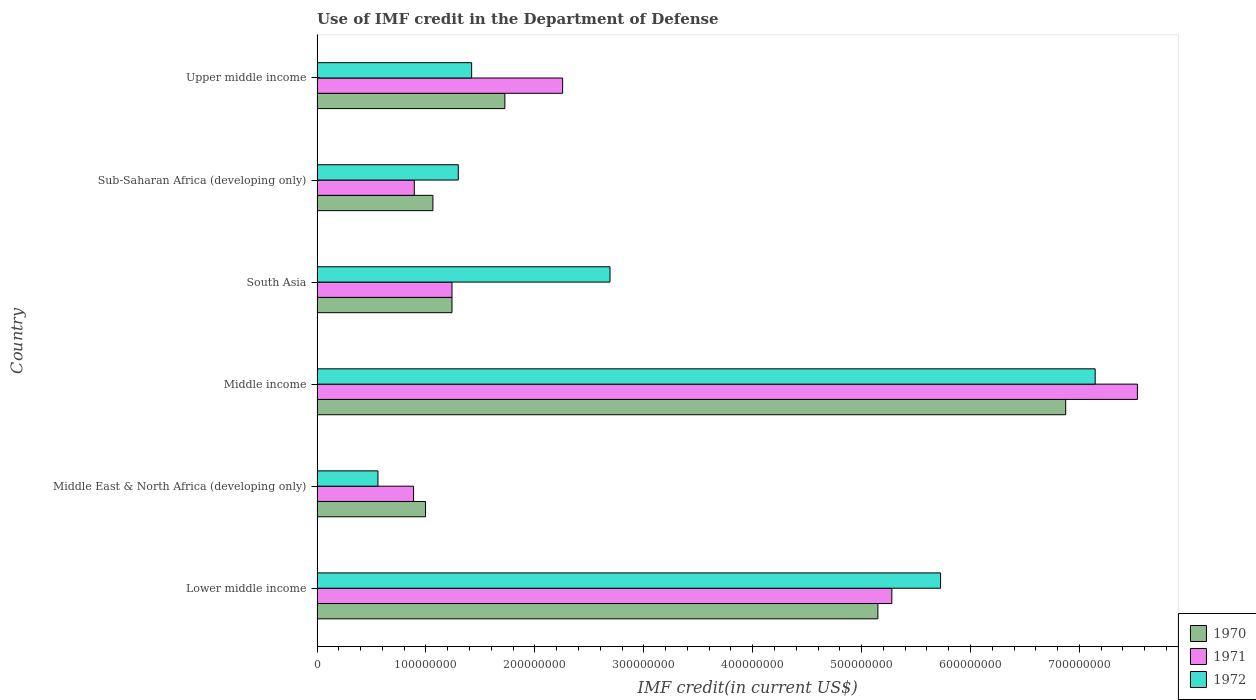How many groups of bars are there?
Ensure brevity in your answer.  6. Are the number of bars per tick equal to the number of legend labels?
Provide a short and direct response. Yes. Are the number of bars on each tick of the Y-axis equal?
Keep it short and to the point. Yes. How many bars are there on the 3rd tick from the bottom?
Offer a terse response. 3. What is the label of the 6th group of bars from the top?
Your response must be concise. Lower middle income. In how many cases, is the number of bars for a given country not equal to the number of legend labels?
Ensure brevity in your answer.  0. What is the IMF credit in the Department of Defense in 1972 in South Asia?
Make the answer very short. 2.69e+08. Across all countries, what is the maximum IMF credit in the Department of Defense in 1970?
Ensure brevity in your answer.  6.87e+08. Across all countries, what is the minimum IMF credit in the Department of Defense in 1970?
Give a very brief answer. 9.96e+07. In which country was the IMF credit in the Department of Defense in 1972 maximum?
Give a very brief answer. Middle income. In which country was the IMF credit in the Department of Defense in 1970 minimum?
Provide a succinct answer. Middle East & North Africa (developing only). What is the total IMF credit in the Department of Defense in 1971 in the graph?
Keep it short and to the point. 1.81e+09. What is the difference between the IMF credit in the Department of Defense in 1970 in Middle East & North Africa (developing only) and that in Sub-Saharan Africa (developing only)?
Keep it short and to the point. -6.78e+06. What is the difference between the IMF credit in the Department of Defense in 1971 in Lower middle income and the IMF credit in the Department of Defense in 1970 in Sub-Saharan Africa (developing only)?
Offer a terse response. 4.21e+08. What is the average IMF credit in the Department of Defense in 1970 per country?
Offer a terse response. 2.84e+08. What is the difference between the IMF credit in the Department of Defense in 1971 and IMF credit in the Department of Defense in 1970 in Middle income?
Keep it short and to the point. 6.58e+07. What is the ratio of the IMF credit in the Department of Defense in 1970 in South Asia to that in Upper middle income?
Your answer should be very brief. 0.72. Is the IMF credit in the Department of Defense in 1971 in Lower middle income less than that in Middle income?
Make the answer very short. Yes. Is the difference between the IMF credit in the Department of Defense in 1971 in Middle East & North Africa (developing only) and Sub-Saharan Africa (developing only) greater than the difference between the IMF credit in the Department of Defense in 1970 in Middle East & North Africa (developing only) and Sub-Saharan Africa (developing only)?
Your response must be concise. Yes. What is the difference between the highest and the second highest IMF credit in the Department of Defense in 1972?
Keep it short and to the point. 1.42e+08. What is the difference between the highest and the lowest IMF credit in the Department of Defense in 1970?
Ensure brevity in your answer.  5.88e+08. In how many countries, is the IMF credit in the Department of Defense in 1972 greater than the average IMF credit in the Department of Defense in 1972 taken over all countries?
Make the answer very short. 2. Is it the case that in every country, the sum of the IMF credit in the Department of Defense in 1971 and IMF credit in the Department of Defense in 1972 is greater than the IMF credit in the Department of Defense in 1970?
Provide a succinct answer. Yes. How many bars are there?
Offer a very short reply. 18. Are all the bars in the graph horizontal?
Give a very brief answer. Yes. How many countries are there in the graph?
Keep it short and to the point. 6. Does the graph contain grids?
Provide a succinct answer. No. Where does the legend appear in the graph?
Give a very brief answer. Bottom right. How many legend labels are there?
Offer a very short reply. 3. How are the legend labels stacked?
Make the answer very short. Vertical. What is the title of the graph?
Make the answer very short. Use of IMF credit in the Department of Defense. What is the label or title of the X-axis?
Offer a very short reply. IMF credit(in current US$). What is the IMF credit(in current US$) in 1970 in Lower middle income?
Make the answer very short. 5.15e+08. What is the IMF credit(in current US$) of 1971 in Lower middle income?
Your answer should be very brief. 5.28e+08. What is the IMF credit(in current US$) in 1972 in Lower middle income?
Make the answer very short. 5.73e+08. What is the IMF credit(in current US$) in 1970 in Middle East & North Africa (developing only)?
Make the answer very short. 9.96e+07. What is the IMF credit(in current US$) of 1971 in Middle East & North Africa (developing only)?
Keep it short and to the point. 8.86e+07. What is the IMF credit(in current US$) in 1972 in Middle East & North Africa (developing only)?
Offer a terse response. 5.59e+07. What is the IMF credit(in current US$) in 1970 in Middle income?
Offer a very short reply. 6.87e+08. What is the IMF credit(in current US$) of 1971 in Middle income?
Offer a terse response. 7.53e+08. What is the IMF credit(in current US$) of 1972 in Middle income?
Make the answer very short. 7.14e+08. What is the IMF credit(in current US$) of 1970 in South Asia?
Offer a very short reply. 1.24e+08. What is the IMF credit(in current US$) in 1971 in South Asia?
Ensure brevity in your answer.  1.24e+08. What is the IMF credit(in current US$) of 1972 in South Asia?
Your response must be concise. 2.69e+08. What is the IMF credit(in current US$) of 1970 in Sub-Saharan Africa (developing only)?
Your answer should be very brief. 1.06e+08. What is the IMF credit(in current US$) of 1971 in Sub-Saharan Africa (developing only)?
Offer a terse response. 8.93e+07. What is the IMF credit(in current US$) in 1972 in Sub-Saharan Africa (developing only)?
Offer a very short reply. 1.30e+08. What is the IMF credit(in current US$) of 1970 in Upper middle income?
Offer a very short reply. 1.72e+08. What is the IMF credit(in current US$) of 1971 in Upper middle income?
Your response must be concise. 2.25e+08. What is the IMF credit(in current US$) in 1972 in Upper middle income?
Your answer should be compact. 1.42e+08. Across all countries, what is the maximum IMF credit(in current US$) in 1970?
Offer a very short reply. 6.87e+08. Across all countries, what is the maximum IMF credit(in current US$) of 1971?
Your response must be concise. 7.53e+08. Across all countries, what is the maximum IMF credit(in current US$) in 1972?
Offer a terse response. 7.14e+08. Across all countries, what is the minimum IMF credit(in current US$) in 1970?
Offer a terse response. 9.96e+07. Across all countries, what is the minimum IMF credit(in current US$) of 1971?
Provide a succinct answer. 8.86e+07. Across all countries, what is the minimum IMF credit(in current US$) of 1972?
Offer a very short reply. 5.59e+07. What is the total IMF credit(in current US$) of 1970 in the graph?
Ensure brevity in your answer.  1.70e+09. What is the total IMF credit(in current US$) in 1971 in the graph?
Provide a succinct answer. 1.81e+09. What is the total IMF credit(in current US$) in 1972 in the graph?
Make the answer very short. 1.88e+09. What is the difference between the IMF credit(in current US$) of 1970 in Lower middle income and that in Middle East & North Africa (developing only)?
Your answer should be compact. 4.15e+08. What is the difference between the IMF credit(in current US$) in 1971 in Lower middle income and that in Middle East & North Africa (developing only)?
Your answer should be compact. 4.39e+08. What is the difference between the IMF credit(in current US$) of 1972 in Lower middle income and that in Middle East & North Africa (developing only)?
Provide a short and direct response. 5.17e+08. What is the difference between the IMF credit(in current US$) in 1970 in Lower middle income and that in Middle income?
Your answer should be compact. -1.72e+08. What is the difference between the IMF credit(in current US$) of 1971 in Lower middle income and that in Middle income?
Offer a terse response. -2.25e+08. What is the difference between the IMF credit(in current US$) in 1972 in Lower middle income and that in Middle income?
Provide a succinct answer. -1.42e+08. What is the difference between the IMF credit(in current US$) in 1970 in Lower middle income and that in South Asia?
Make the answer very short. 3.91e+08. What is the difference between the IMF credit(in current US$) in 1971 in Lower middle income and that in South Asia?
Your response must be concise. 4.04e+08. What is the difference between the IMF credit(in current US$) of 1972 in Lower middle income and that in South Asia?
Your response must be concise. 3.04e+08. What is the difference between the IMF credit(in current US$) of 1970 in Lower middle income and that in Sub-Saharan Africa (developing only)?
Give a very brief answer. 4.09e+08. What is the difference between the IMF credit(in current US$) of 1971 in Lower middle income and that in Sub-Saharan Africa (developing only)?
Give a very brief answer. 4.38e+08. What is the difference between the IMF credit(in current US$) of 1972 in Lower middle income and that in Sub-Saharan Africa (developing only)?
Offer a very short reply. 4.43e+08. What is the difference between the IMF credit(in current US$) of 1970 in Lower middle income and that in Upper middle income?
Make the answer very short. 3.43e+08. What is the difference between the IMF credit(in current US$) of 1971 in Lower middle income and that in Upper middle income?
Your answer should be compact. 3.02e+08. What is the difference between the IMF credit(in current US$) of 1972 in Lower middle income and that in Upper middle income?
Offer a very short reply. 4.31e+08. What is the difference between the IMF credit(in current US$) of 1970 in Middle East & North Africa (developing only) and that in Middle income?
Your answer should be compact. -5.88e+08. What is the difference between the IMF credit(in current US$) in 1971 in Middle East & North Africa (developing only) and that in Middle income?
Your answer should be compact. -6.65e+08. What is the difference between the IMF credit(in current US$) in 1972 in Middle East & North Africa (developing only) and that in Middle income?
Provide a short and direct response. -6.59e+08. What is the difference between the IMF credit(in current US$) of 1970 in Middle East & North Africa (developing only) and that in South Asia?
Ensure brevity in your answer.  -2.43e+07. What is the difference between the IMF credit(in current US$) of 1971 in Middle East & North Africa (developing only) and that in South Asia?
Offer a terse response. -3.53e+07. What is the difference between the IMF credit(in current US$) in 1972 in Middle East & North Africa (developing only) and that in South Asia?
Ensure brevity in your answer.  -2.13e+08. What is the difference between the IMF credit(in current US$) in 1970 in Middle East & North Africa (developing only) and that in Sub-Saharan Africa (developing only)?
Your response must be concise. -6.78e+06. What is the difference between the IMF credit(in current US$) of 1971 in Middle East & North Africa (developing only) and that in Sub-Saharan Africa (developing only)?
Your answer should be very brief. -6.60e+05. What is the difference between the IMF credit(in current US$) of 1972 in Middle East & North Africa (developing only) and that in Sub-Saharan Africa (developing only)?
Provide a short and direct response. -7.38e+07. What is the difference between the IMF credit(in current US$) of 1970 in Middle East & North Africa (developing only) and that in Upper middle income?
Offer a terse response. -7.28e+07. What is the difference between the IMF credit(in current US$) of 1971 in Middle East & North Africa (developing only) and that in Upper middle income?
Your answer should be compact. -1.37e+08. What is the difference between the IMF credit(in current US$) in 1972 in Middle East & North Africa (developing only) and that in Upper middle income?
Offer a very short reply. -8.60e+07. What is the difference between the IMF credit(in current US$) in 1970 in Middle income and that in South Asia?
Your response must be concise. 5.64e+08. What is the difference between the IMF credit(in current US$) in 1971 in Middle income and that in South Asia?
Ensure brevity in your answer.  6.29e+08. What is the difference between the IMF credit(in current US$) of 1972 in Middle income and that in South Asia?
Your answer should be very brief. 4.45e+08. What is the difference between the IMF credit(in current US$) in 1970 in Middle income and that in Sub-Saharan Africa (developing only)?
Provide a short and direct response. 5.81e+08. What is the difference between the IMF credit(in current US$) in 1971 in Middle income and that in Sub-Saharan Africa (developing only)?
Your answer should be very brief. 6.64e+08. What is the difference between the IMF credit(in current US$) of 1972 in Middle income and that in Sub-Saharan Africa (developing only)?
Ensure brevity in your answer.  5.85e+08. What is the difference between the IMF credit(in current US$) of 1970 in Middle income and that in Upper middle income?
Your response must be concise. 5.15e+08. What is the difference between the IMF credit(in current US$) of 1971 in Middle income and that in Upper middle income?
Give a very brief answer. 5.28e+08. What is the difference between the IMF credit(in current US$) in 1972 in Middle income and that in Upper middle income?
Your answer should be very brief. 5.73e+08. What is the difference between the IMF credit(in current US$) of 1970 in South Asia and that in Sub-Saharan Africa (developing only)?
Give a very brief answer. 1.75e+07. What is the difference between the IMF credit(in current US$) in 1971 in South Asia and that in Sub-Saharan Africa (developing only)?
Provide a succinct answer. 3.46e+07. What is the difference between the IMF credit(in current US$) of 1972 in South Asia and that in Sub-Saharan Africa (developing only)?
Your response must be concise. 1.39e+08. What is the difference between the IMF credit(in current US$) in 1970 in South Asia and that in Upper middle income?
Ensure brevity in your answer.  -4.86e+07. What is the difference between the IMF credit(in current US$) in 1971 in South Asia and that in Upper middle income?
Offer a terse response. -1.02e+08. What is the difference between the IMF credit(in current US$) of 1972 in South Asia and that in Upper middle income?
Keep it short and to the point. 1.27e+08. What is the difference between the IMF credit(in current US$) of 1970 in Sub-Saharan Africa (developing only) and that in Upper middle income?
Your answer should be very brief. -6.61e+07. What is the difference between the IMF credit(in current US$) in 1971 in Sub-Saharan Africa (developing only) and that in Upper middle income?
Your answer should be very brief. -1.36e+08. What is the difference between the IMF credit(in current US$) in 1972 in Sub-Saharan Africa (developing only) and that in Upper middle income?
Provide a short and direct response. -1.23e+07. What is the difference between the IMF credit(in current US$) of 1970 in Lower middle income and the IMF credit(in current US$) of 1971 in Middle East & North Africa (developing only)?
Your answer should be compact. 4.26e+08. What is the difference between the IMF credit(in current US$) of 1970 in Lower middle income and the IMF credit(in current US$) of 1972 in Middle East & North Africa (developing only)?
Make the answer very short. 4.59e+08. What is the difference between the IMF credit(in current US$) of 1971 in Lower middle income and the IMF credit(in current US$) of 1972 in Middle East & North Africa (developing only)?
Your answer should be compact. 4.72e+08. What is the difference between the IMF credit(in current US$) of 1970 in Lower middle income and the IMF credit(in current US$) of 1971 in Middle income?
Keep it short and to the point. -2.38e+08. What is the difference between the IMF credit(in current US$) in 1970 in Lower middle income and the IMF credit(in current US$) in 1972 in Middle income?
Make the answer very short. -2.00e+08. What is the difference between the IMF credit(in current US$) of 1971 in Lower middle income and the IMF credit(in current US$) of 1972 in Middle income?
Offer a terse response. -1.87e+08. What is the difference between the IMF credit(in current US$) of 1970 in Lower middle income and the IMF credit(in current US$) of 1971 in South Asia?
Your response must be concise. 3.91e+08. What is the difference between the IMF credit(in current US$) of 1970 in Lower middle income and the IMF credit(in current US$) of 1972 in South Asia?
Give a very brief answer. 2.46e+08. What is the difference between the IMF credit(in current US$) of 1971 in Lower middle income and the IMF credit(in current US$) of 1972 in South Asia?
Offer a very short reply. 2.59e+08. What is the difference between the IMF credit(in current US$) in 1970 in Lower middle income and the IMF credit(in current US$) in 1971 in Sub-Saharan Africa (developing only)?
Provide a succinct answer. 4.26e+08. What is the difference between the IMF credit(in current US$) in 1970 in Lower middle income and the IMF credit(in current US$) in 1972 in Sub-Saharan Africa (developing only)?
Provide a short and direct response. 3.85e+08. What is the difference between the IMF credit(in current US$) of 1971 in Lower middle income and the IMF credit(in current US$) of 1972 in Sub-Saharan Africa (developing only)?
Your response must be concise. 3.98e+08. What is the difference between the IMF credit(in current US$) in 1970 in Lower middle income and the IMF credit(in current US$) in 1971 in Upper middle income?
Offer a very short reply. 2.89e+08. What is the difference between the IMF credit(in current US$) in 1970 in Lower middle income and the IMF credit(in current US$) in 1972 in Upper middle income?
Provide a succinct answer. 3.73e+08. What is the difference between the IMF credit(in current US$) of 1971 in Lower middle income and the IMF credit(in current US$) of 1972 in Upper middle income?
Offer a very short reply. 3.86e+08. What is the difference between the IMF credit(in current US$) in 1970 in Middle East & North Africa (developing only) and the IMF credit(in current US$) in 1971 in Middle income?
Give a very brief answer. -6.54e+08. What is the difference between the IMF credit(in current US$) in 1970 in Middle East & North Africa (developing only) and the IMF credit(in current US$) in 1972 in Middle income?
Provide a short and direct response. -6.15e+08. What is the difference between the IMF credit(in current US$) in 1971 in Middle East & North Africa (developing only) and the IMF credit(in current US$) in 1972 in Middle income?
Your answer should be compact. -6.26e+08. What is the difference between the IMF credit(in current US$) in 1970 in Middle East & North Africa (developing only) and the IMF credit(in current US$) in 1971 in South Asia?
Your answer should be very brief. -2.43e+07. What is the difference between the IMF credit(in current US$) of 1970 in Middle East & North Africa (developing only) and the IMF credit(in current US$) of 1972 in South Asia?
Give a very brief answer. -1.69e+08. What is the difference between the IMF credit(in current US$) of 1971 in Middle East & North Africa (developing only) and the IMF credit(in current US$) of 1972 in South Asia?
Your answer should be very brief. -1.80e+08. What is the difference between the IMF credit(in current US$) in 1970 in Middle East & North Africa (developing only) and the IMF credit(in current US$) in 1971 in Sub-Saharan Africa (developing only)?
Give a very brief answer. 1.03e+07. What is the difference between the IMF credit(in current US$) in 1970 in Middle East & North Africa (developing only) and the IMF credit(in current US$) in 1972 in Sub-Saharan Africa (developing only)?
Provide a short and direct response. -3.01e+07. What is the difference between the IMF credit(in current US$) of 1971 in Middle East & North Africa (developing only) and the IMF credit(in current US$) of 1972 in Sub-Saharan Africa (developing only)?
Offer a terse response. -4.11e+07. What is the difference between the IMF credit(in current US$) in 1970 in Middle East & North Africa (developing only) and the IMF credit(in current US$) in 1971 in Upper middle income?
Give a very brief answer. -1.26e+08. What is the difference between the IMF credit(in current US$) of 1970 in Middle East & North Africa (developing only) and the IMF credit(in current US$) of 1972 in Upper middle income?
Give a very brief answer. -4.23e+07. What is the difference between the IMF credit(in current US$) in 1971 in Middle East & North Africa (developing only) and the IMF credit(in current US$) in 1972 in Upper middle income?
Your answer should be very brief. -5.33e+07. What is the difference between the IMF credit(in current US$) in 1970 in Middle income and the IMF credit(in current US$) in 1971 in South Asia?
Make the answer very short. 5.64e+08. What is the difference between the IMF credit(in current US$) of 1970 in Middle income and the IMF credit(in current US$) of 1972 in South Asia?
Ensure brevity in your answer.  4.18e+08. What is the difference between the IMF credit(in current US$) of 1971 in Middle income and the IMF credit(in current US$) of 1972 in South Asia?
Your answer should be compact. 4.84e+08. What is the difference between the IMF credit(in current US$) of 1970 in Middle income and the IMF credit(in current US$) of 1971 in Sub-Saharan Africa (developing only)?
Ensure brevity in your answer.  5.98e+08. What is the difference between the IMF credit(in current US$) in 1970 in Middle income and the IMF credit(in current US$) in 1972 in Sub-Saharan Africa (developing only)?
Make the answer very short. 5.58e+08. What is the difference between the IMF credit(in current US$) in 1971 in Middle income and the IMF credit(in current US$) in 1972 in Sub-Saharan Africa (developing only)?
Offer a very short reply. 6.24e+08. What is the difference between the IMF credit(in current US$) of 1970 in Middle income and the IMF credit(in current US$) of 1971 in Upper middle income?
Provide a short and direct response. 4.62e+08. What is the difference between the IMF credit(in current US$) of 1970 in Middle income and the IMF credit(in current US$) of 1972 in Upper middle income?
Your response must be concise. 5.45e+08. What is the difference between the IMF credit(in current US$) in 1971 in Middle income and the IMF credit(in current US$) in 1972 in Upper middle income?
Offer a very short reply. 6.11e+08. What is the difference between the IMF credit(in current US$) in 1970 in South Asia and the IMF credit(in current US$) in 1971 in Sub-Saharan Africa (developing only)?
Make the answer very short. 3.46e+07. What is the difference between the IMF credit(in current US$) of 1970 in South Asia and the IMF credit(in current US$) of 1972 in Sub-Saharan Africa (developing only)?
Offer a very short reply. -5.79e+06. What is the difference between the IMF credit(in current US$) of 1971 in South Asia and the IMF credit(in current US$) of 1972 in Sub-Saharan Africa (developing only)?
Your response must be concise. -5.79e+06. What is the difference between the IMF credit(in current US$) in 1970 in South Asia and the IMF credit(in current US$) in 1971 in Upper middle income?
Offer a terse response. -1.02e+08. What is the difference between the IMF credit(in current US$) in 1970 in South Asia and the IMF credit(in current US$) in 1972 in Upper middle income?
Your answer should be very brief. -1.80e+07. What is the difference between the IMF credit(in current US$) of 1971 in South Asia and the IMF credit(in current US$) of 1972 in Upper middle income?
Your response must be concise. -1.80e+07. What is the difference between the IMF credit(in current US$) in 1970 in Sub-Saharan Africa (developing only) and the IMF credit(in current US$) in 1971 in Upper middle income?
Your answer should be compact. -1.19e+08. What is the difference between the IMF credit(in current US$) in 1970 in Sub-Saharan Africa (developing only) and the IMF credit(in current US$) in 1972 in Upper middle income?
Make the answer very short. -3.56e+07. What is the difference between the IMF credit(in current US$) of 1971 in Sub-Saharan Africa (developing only) and the IMF credit(in current US$) of 1972 in Upper middle income?
Provide a succinct answer. -5.27e+07. What is the average IMF credit(in current US$) in 1970 per country?
Provide a succinct answer. 2.84e+08. What is the average IMF credit(in current US$) in 1971 per country?
Your response must be concise. 3.01e+08. What is the average IMF credit(in current US$) in 1972 per country?
Your response must be concise. 3.14e+08. What is the difference between the IMF credit(in current US$) of 1970 and IMF credit(in current US$) of 1971 in Lower middle income?
Make the answer very short. -1.28e+07. What is the difference between the IMF credit(in current US$) in 1970 and IMF credit(in current US$) in 1972 in Lower middle income?
Provide a succinct answer. -5.76e+07. What is the difference between the IMF credit(in current US$) in 1971 and IMF credit(in current US$) in 1972 in Lower middle income?
Make the answer very short. -4.48e+07. What is the difference between the IMF credit(in current US$) of 1970 and IMF credit(in current US$) of 1971 in Middle East & North Africa (developing only)?
Your response must be concise. 1.10e+07. What is the difference between the IMF credit(in current US$) of 1970 and IMF credit(in current US$) of 1972 in Middle East & North Africa (developing only)?
Ensure brevity in your answer.  4.37e+07. What is the difference between the IMF credit(in current US$) in 1971 and IMF credit(in current US$) in 1972 in Middle East & North Africa (developing only)?
Make the answer very short. 3.27e+07. What is the difference between the IMF credit(in current US$) in 1970 and IMF credit(in current US$) in 1971 in Middle income?
Provide a short and direct response. -6.58e+07. What is the difference between the IMF credit(in current US$) of 1970 and IMF credit(in current US$) of 1972 in Middle income?
Give a very brief answer. -2.71e+07. What is the difference between the IMF credit(in current US$) in 1971 and IMF credit(in current US$) in 1972 in Middle income?
Your response must be concise. 3.88e+07. What is the difference between the IMF credit(in current US$) of 1970 and IMF credit(in current US$) of 1972 in South Asia?
Offer a very short reply. -1.45e+08. What is the difference between the IMF credit(in current US$) in 1971 and IMF credit(in current US$) in 1972 in South Asia?
Provide a short and direct response. -1.45e+08. What is the difference between the IMF credit(in current US$) of 1970 and IMF credit(in current US$) of 1971 in Sub-Saharan Africa (developing only)?
Provide a succinct answer. 1.71e+07. What is the difference between the IMF credit(in current US$) in 1970 and IMF credit(in current US$) in 1972 in Sub-Saharan Africa (developing only)?
Your answer should be compact. -2.33e+07. What is the difference between the IMF credit(in current US$) in 1971 and IMF credit(in current US$) in 1972 in Sub-Saharan Africa (developing only)?
Ensure brevity in your answer.  -4.04e+07. What is the difference between the IMF credit(in current US$) of 1970 and IMF credit(in current US$) of 1971 in Upper middle income?
Make the answer very short. -5.30e+07. What is the difference between the IMF credit(in current US$) of 1970 and IMF credit(in current US$) of 1972 in Upper middle income?
Your response must be concise. 3.05e+07. What is the difference between the IMF credit(in current US$) of 1971 and IMF credit(in current US$) of 1972 in Upper middle income?
Make the answer very short. 8.35e+07. What is the ratio of the IMF credit(in current US$) in 1970 in Lower middle income to that in Middle East & North Africa (developing only)?
Provide a short and direct response. 5.17. What is the ratio of the IMF credit(in current US$) in 1971 in Lower middle income to that in Middle East & North Africa (developing only)?
Provide a short and direct response. 5.95. What is the ratio of the IMF credit(in current US$) of 1972 in Lower middle income to that in Middle East & North Africa (developing only)?
Make the answer very short. 10.24. What is the ratio of the IMF credit(in current US$) in 1970 in Lower middle income to that in Middle income?
Ensure brevity in your answer.  0.75. What is the ratio of the IMF credit(in current US$) in 1971 in Lower middle income to that in Middle income?
Give a very brief answer. 0.7. What is the ratio of the IMF credit(in current US$) of 1972 in Lower middle income to that in Middle income?
Ensure brevity in your answer.  0.8. What is the ratio of the IMF credit(in current US$) of 1970 in Lower middle income to that in South Asia?
Your answer should be very brief. 4.16. What is the ratio of the IMF credit(in current US$) in 1971 in Lower middle income to that in South Asia?
Your answer should be very brief. 4.26. What is the ratio of the IMF credit(in current US$) of 1972 in Lower middle income to that in South Asia?
Your response must be concise. 2.13. What is the ratio of the IMF credit(in current US$) of 1970 in Lower middle income to that in Sub-Saharan Africa (developing only)?
Provide a short and direct response. 4.84. What is the ratio of the IMF credit(in current US$) in 1971 in Lower middle income to that in Sub-Saharan Africa (developing only)?
Your answer should be compact. 5.91. What is the ratio of the IMF credit(in current US$) of 1972 in Lower middle income to that in Sub-Saharan Africa (developing only)?
Provide a short and direct response. 4.41. What is the ratio of the IMF credit(in current US$) in 1970 in Lower middle income to that in Upper middle income?
Give a very brief answer. 2.99. What is the ratio of the IMF credit(in current US$) in 1971 in Lower middle income to that in Upper middle income?
Give a very brief answer. 2.34. What is the ratio of the IMF credit(in current US$) of 1972 in Lower middle income to that in Upper middle income?
Your response must be concise. 4.03. What is the ratio of the IMF credit(in current US$) in 1970 in Middle East & North Africa (developing only) to that in Middle income?
Your answer should be very brief. 0.14. What is the ratio of the IMF credit(in current US$) of 1971 in Middle East & North Africa (developing only) to that in Middle income?
Your answer should be very brief. 0.12. What is the ratio of the IMF credit(in current US$) in 1972 in Middle East & North Africa (developing only) to that in Middle income?
Make the answer very short. 0.08. What is the ratio of the IMF credit(in current US$) of 1970 in Middle East & North Africa (developing only) to that in South Asia?
Offer a terse response. 0.8. What is the ratio of the IMF credit(in current US$) of 1971 in Middle East & North Africa (developing only) to that in South Asia?
Your answer should be compact. 0.72. What is the ratio of the IMF credit(in current US$) of 1972 in Middle East & North Africa (developing only) to that in South Asia?
Provide a short and direct response. 0.21. What is the ratio of the IMF credit(in current US$) in 1970 in Middle East & North Africa (developing only) to that in Sub-Saharan Africa (developing only)?
Offer a very short reply. 0.94. What is the ratio of the IMF credit(in current US$) of 1971 in Middle East & North Africa (developing only) to that in Sub-Saharan Africa (developing only)?
Make the answer very short. 0.99. What is the ratio of the IMF credit(in current US$) in 1972 in Middle East & North Africa (developing only) to that in Sub-Saharan Africa (developing only)?
Offer a terse response. 0.43. What is the ratio of the IMF credit(in current US$) of 1970 in Middle East & North Africa (developing only) to that in Upper middle income?
Make the answer very short. 0.58. What is the ratio of the IMF credit(in current US$) of 1971 in Middle East & North Africa (developing only) to that in Upper middle income?
Give a very brief answer. 0.39. What is the ratio of the IMF credit(in current US$) of 1972 in Middle East & North Africa (developing only) to that in Upper middle income?
Your answer should be compact. 0.39. What is the ratio of the IMF credit(in current US$) in 1970 in Middle income to that in South Asia?
Your answer should be very brief. 5.55. What is the ratio of the IMF credit(in current US$) in 1971 in Middle income to that in South Asia?
Offer a terse response. 6.08. What is the ratio of the IMF credit(in current US$) in 1972 in Middle income to that in South Asia?
Offer a terse response. 2.66. What is the ratio of the IMF credit(in current US$) of 1970 in Middle income to that in Sub-Saharan Africa (developing only)?
Give a very brief answer. 6.46. What is the ratio of the IMF credit(in current US$) in 1971 in Middle income to that in Sub-Saharan Africa (developing only)?
Your answer should be very brief. 8.44. What is the ratio of the IMF credit(in current US$) of 1972 in Middle income to that in Sub-Saharan Africa (developing only)?
Your answer should be very brief. 5.51. What is the ratio of the IMF credit(in current US$) in 1970 in Middle income to that in Upper middle income?
Your response must be concise. 3.99. What is the ratio of the IMF credit(in current US$) of 1971 in Middle income to that in Upper middle income?
Keep it short and to the point. 3.34. What is the ratio of the IMF credit(in current US$) of 1972 in Middle income to that in Upper middle income?
Ensure brevity in your answer.  5.03. What is the ratio of the IMF credit(in current US$) of 1970 in South Asia to that in Sub-Saharan Africa (developing only)?
Ensure brevity in your answer.  1.16. What is the ratio of the IMF credit(in current US$) in 1971 in South Asia to that in Sub-Saharan Africa (developing only)?
Your response must be concise. 1.39. What is the ratio of the IMF credit(in current US$) of 1972 in South Asia to that in Sub-Saharan Africa (developing only)?
Provide a short and direct response. 2.07. What is the ratio of the IMF credit(in current US$) in 1970 in South Asia to that in Upper middle income?
Your response must be concise. 0.72. What is the ratio of the IMF credit(in current US$) of 1971 in South Asia to that in Upper middle income?
Your answer should be compact. 0.55. What is the ratio of the IMF credit(in current US$) of 1972 in South Asia to that in Upper middle income?
Your answer should be compact. 1.9. What is the ratio of the IMF credit(in current US$) of 1970 in Sub-Saharan Africa (developing only) to that in Upper middle income?
Your response must be concise. 0.62. What is the ratio of the IMF credit(in current US$) in 1971 in Sub-Saharan Africa (developing only) to that in Upper middle income?
Make the answer very short. 0.4. What is the ratio of the IMF credit(in current US$) of 1972 in Sub-Saharan Africa (developing only) to that in Upper middle income?
Your answer should be very brief. 0.91. What is the difference between the highest and the second highest IMF credit(in current US$) of 1970?
Your answer should be very brief. 1.72e+08. What is the difference between the highest and the second highest IMF credit(in current US$) in 1971?
Ensure brevity in your answer.  2.25e+08. What is the difference between the highest and the second highest IMF credit(in current US$) in 1972?
Keep it short and to the point. 1.42e+08. What is the difference between the highest and the lowest IMF credit(in current US$) in 1970?
Your answer should be very brief. 5.88e+08. What is the difference between the highest and the lowest IMF credit(in current US$) of 1971?
Make the answer very short. 6.65e+08. What is the difference between the highest and the lowest IMF credit(in current US$) of 1972?
Provide a succinct answer. 6.59e+08. 